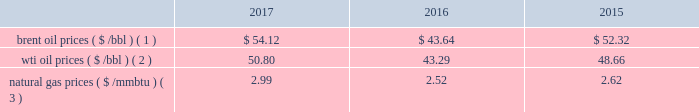Bhge 2017 form 10-k | 27 the short term .
We do , however , view the long term economics of the lng industry as positive given our outlook for supply and demand .
2022 refinery , petrochemical and industrial projects : in refining , we believe large , complex refineries should gain advantage in a more competitive , oversupplied landscape in 2018 as the industry globalizes and refiners position to meet local demand and secure export potential .
In petrochemicals , we continue to see healthy demand and cost-advantaged supply driving projects forward in 2018 .
The industrial market continues to grow as outdated infrastructure is replaced , policy changes come into effect and power is decentralized .
We continue to see growing demand across these markets in 2018 .
We have other segments in our portfolio that are more correlated with different industrial metrics such as our digital solutions business .
Overall , we believe our portfolio is uniquely positioned to compete across the value chain , and deliver unique solutions for our customers .
We remain optimistic about the long-term economics of the industry , but are continuing to operate with flexibility given our expectations for volatility and changing assumptions in the near term .
In 2016 , solar and wind net additions exceeded coal and gas for the first time and it continued throughout 2017 .
Governments may change or may not continue incentives for renewable energy additions .
In the long term , renewables' cost decline may accelerate to compete with new-built fossil capacity , however , we do not anticipate any significant impacts to our business in the foreseeable future .
Despite the near-term volatility , the long-term outlook for our industry remains strong .
We believe the world 2019s demand for energy will continue to rise , and the supply of energy will continue to increase in complexity , requiring greater service intensity and more advanced technology from oilfield service companies .
As such , we remain focused on delivering innovative cost-efficient solutions that deliver step changes in operating and economic performance for our customers .
Business environment the following discussion and analysis summarizes the significant factors affecting our results of operations , financial condition and liquidity position as of and for the year ended december 31 , 2017 , 2016 and 2015 , and should be read in conjunction with the consolidated and combined financial statements and related notes of the company .
Amounts reported in millions in graphs within this report are computed based on the amounts in hundreds .
As a result , the sum of the components reported in millions may not equal the total amount reported in millions due to rounding .
We operate in more than 120 countries helping customers find , evaluate , drill , produce , transport and process hydrocarbon resources .
Our revenue is predominately generated from the sale of products and services to major , national , and independent oil and natural gas companies worldwide , and is dependent on spending by our customers for oil and natural gas exploration , field development and production .
This spending is driven by a number of factors , including our customers' forecasts of future energy demand and supply , their access to resources to develop and produce oil and natural gas , their ability to fund their capital programs , the impact of new government regulations and most importantly , their expectations for oil and natural gas prices as a key driver of their cash flows .
Oil and natural gas prices oil and natural gas prices are summarized in the table below as averages of the daily closing prices during each of the periods indicated. .
Brent oil prices ( $ /bbl ) ( 1 ) $ 54.12 $ 43.64 $ 52.32 wti oil prices ( $ /bbl ) ( 2 ) 50.80 43.29 48.66 natural gas prices ( $ /mmbtu ) ( 3 ) 2.99 2.52 2.62 ( 1 ) energy information administration ( eia ) europe brent spot price per barrel .
What are the natural gas prices as a percentage of wti oil prices in 2017? 
Computations: (2.99 / 50.80)
Answer: 0.05886. 